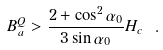Convert formula to latex. <formula><loc_0><loc_0><loc_500><loc_500>B _ { a } ^ { Q } > \frac { 2 + \cos ^ { 2 } \alpha _ { 0 } } { 3 \sin \alpha _ { 0 } } H _ { c } \ .</formula> 